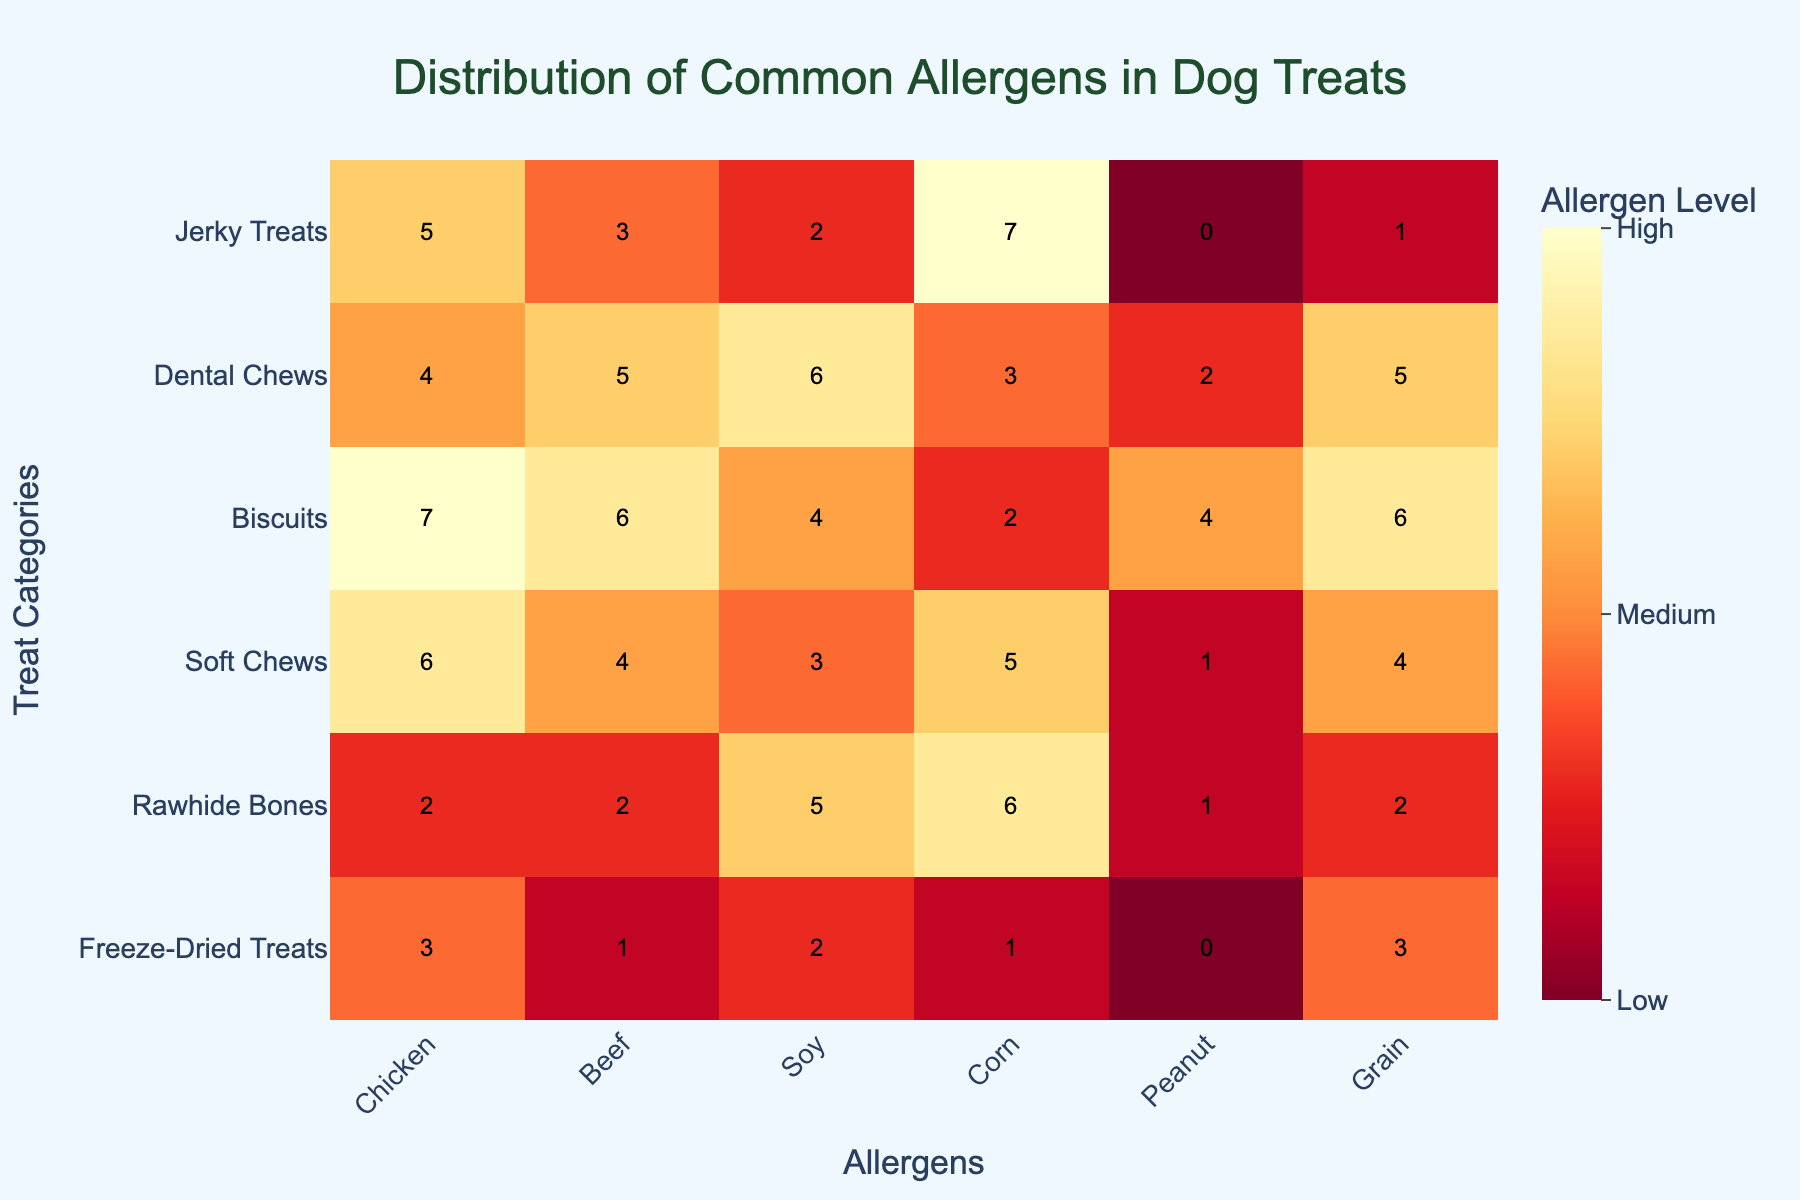What allergen appears most frequently in the "Biscuits" treat category? Check the row for "Biscuits" and identify which allergen has the highest value. The highest value in the "Biscuits" row corresponds to Chicken with a level of 7.
Answer: Chicken Which treat category contains the highest level of Corn allergen? Look at the Corn column and identify which row has the highest value. The row for "Jerky Treats" has the highest Corn allergen level of 7.
Answer: Jerky Treats What is the average allergen level in the "Dental Chews" treat category? Sum the allergen levels in the "Dental Chews" row and divide by the number of allergens. The sum is 4 + 5 + 6 + 3 + 2 + 5 = 25. There are 6 allergens, so the average is 25 / 6 ≈ 4.17.
Answer: 4.17 How does the allergen level of Soy in "Soft Chews" compare to "Freeze-Dried Treats"? Compare the values in the Soy column for "Soft Chews" and "Freeze-Dried Treats". "Soft Chews" has a level of 3, and "Freeze-Dried Treats" has a level of 2, so "Soft Chews" has a higher level of Soy allergen.
Answer: Higher in Soft Chews Which treat category has the lowest level of Peanut allergen? Check the Peanut column and identify the row with the lowest value. Both "Jerky Treats" and "Freeze-Dried Treats" have the lowest level of Peanut allergen at 0.
Answer: Jerky Treats, Freeze-Dried Treats What is the combined allergen level of Chicken and Beef in "Rawhide Bones"? Sum the Chicken and Beef allergen levels in the "Rawhide Bones" row. The values are 2 (Chicken) and 2 (Beef), so the combined level is 2 + 2 = 4.
Answer: 4 Does any treat category have a medium level of all allergens? "Medium" level corresponds to values between approximately 2 and 5. Scan each row to see if all values fall within this range. No row has all values between 2 and 5.
Answer: No Which allergen has the highest variation in levels across different treat categories? Calculate the range (max - min) for each allergen. Chicken has the highest range, from 2 to 7, with a variation of 7 - 2 = 5.
Answer: Chicken 